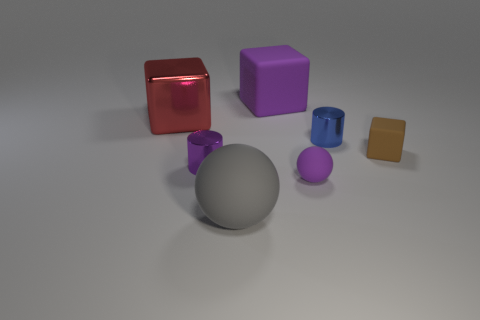Are there fewer big balls than purple rubber objects?
Offer a terse response. Yes. How many big matte objects have the same shape as the tiny brown object?
Make the answer very short. 1. There is a matte object that is the same size as the purple matte cube; what is its color?
Provide a succinct answer. Gray. Are there the same number of metallic cubes that are to the right of the small brown cube and rubber cubes behind the big purple rubber thing?
Provide a short and direct response. Yes. Are there any brown rubber objects of the same size as the purple cube?
Your answer should be compact. No. What size is the gray matte ball?
Your answer should be compact. Large. Is the number of tiny purple matte objects left of the large purple rubber thing the same as the number of brown metallic objects?
Your response must be concise. Yes. How many other objects are the same color as the tiny rubber cube?
Your answer should be compact. 0. There is a object that is both on the right side of the red metallic thing and to the left of the gray object; what color is it?
Make the answer very short. Purple. What is the size of the cylinder that is to the right of the rubber sphere to the right of the large thing that is behind the large metal block?
Make the answer very short. Small. 